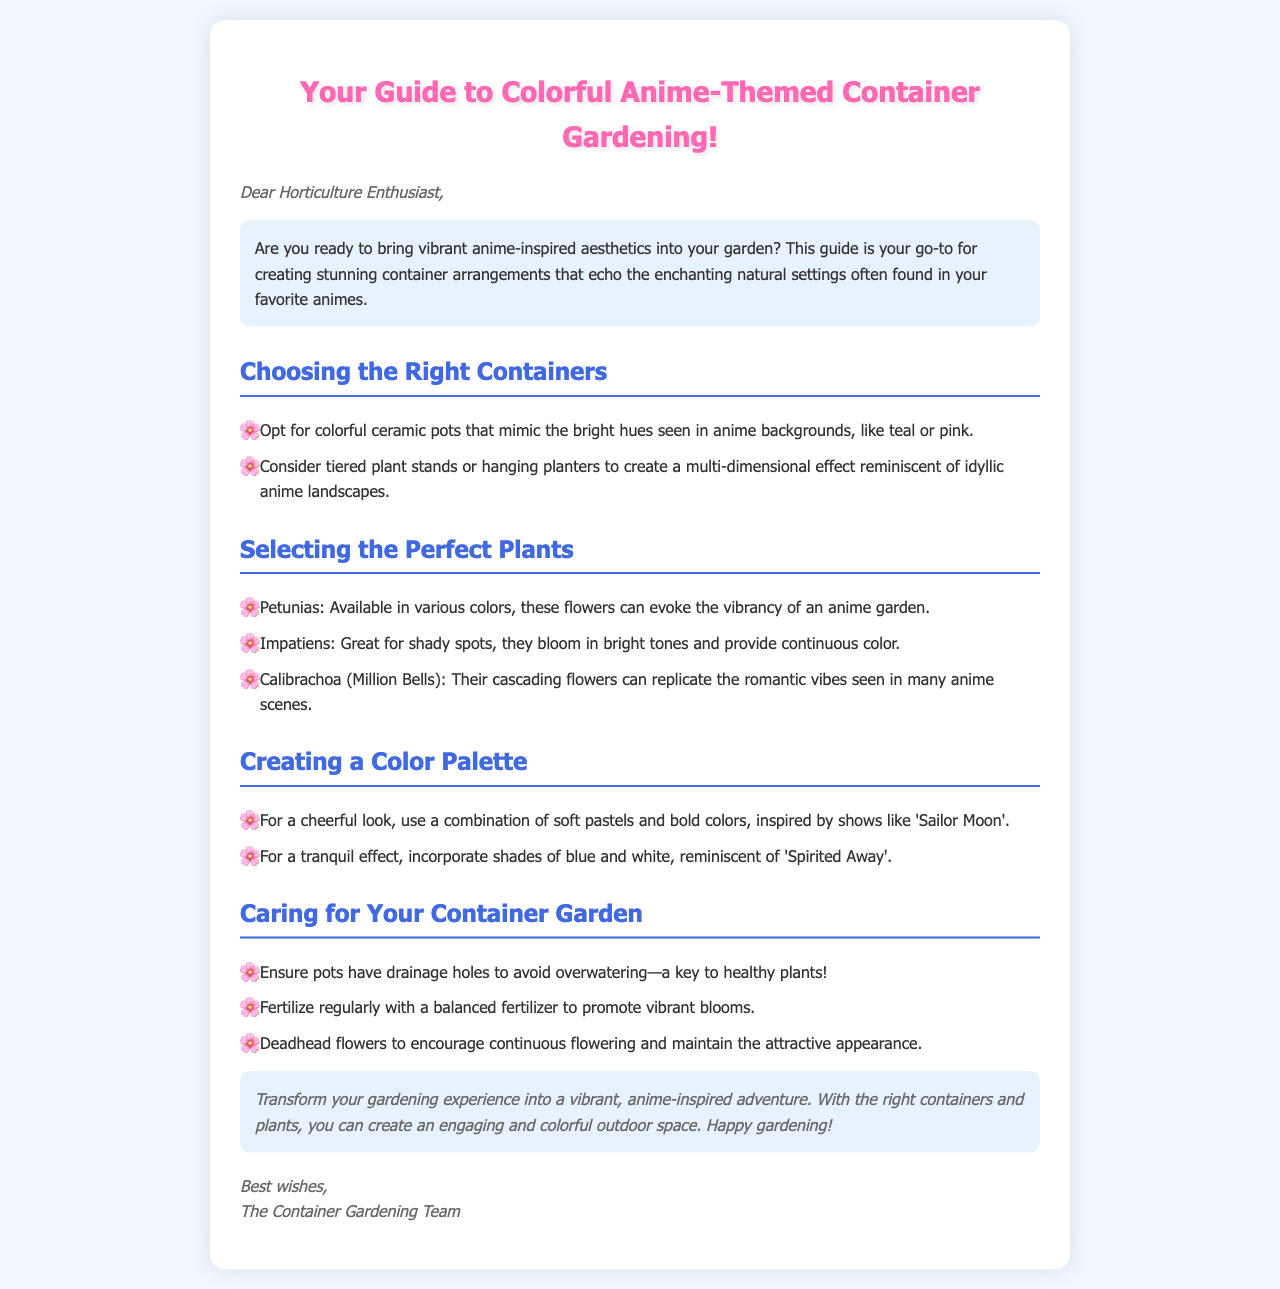What is the main theme of the guide? The main theme of the guide is about creating colorful container arrangements inspired by anime aesthetics.
Answer: Colorful anime-themed container gardening What is a recommended plant for shady spots? The guide suggests Impatiens for shady areas due to their continuous bright blooms.
Answer: Impatiens What color combination inspires a cheerful look? The guide states a combination of soft pastels and bold colors, inspired by 'Sailor Moon', creates a cheerful appearance.
Answer: Soft pastels and bold colors What is one key care instruction for the container garden? One important care instruction mentioned is to ensure pots have drainage holes to avoid overwatering.
Answer: Ensure pots have drainage holes What is the suggested fertilizer type for vibrant blooms? The document recommends using a balanced fertilizer to promote vibrant blooms in the container garden.
Answer: Balanced fertilizer 